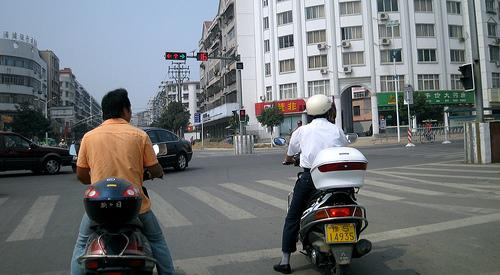In your own words, sum up the image contents in brief. Two bikers in colorful shirts on mopeds stop at a traffic light near a white corner building with green and white street signs. Briefly describe the setting and context of the image. An urban intersection featuring a white corner building, traffic lights, street signs, and two men riding mopeds. Provide a concise description of the most prominent features in the image. Two men on motorcycles stopped at a traffic light near a white building and crosswalk with traffic lights overhead. In one sentence, describe the action taking place in the image. Two men on mopeds pause at a traffic light near a white building and crosswalk. Provide a short and catchy caption for the image. "Motorcycle Diaries: Urban roads edition" Explain the type of scene being depicted in the image in one sentence. An urban street scene with two moped riders waiting at a traffic light intersection near a white building. Identify the three most noticeable objects in the image and their colors. Two riders wearing an orange and white shirt, a white building, and traffic lights over an intersection. Mention the key elements in the image and their positions related to each other. Two men ride mopeds near an intersection with traffic lights above, a white building on the corner and white lines of the crosswalk in front. Describe the most striking element from the image and explain why it's interesting. A man wearing an orange shirt is riding a moped, which stands out due to its vibrant color in the midst of the urban backdrop Describe the attire and position of the two individuals in the image. One man in an orange shirt and blue jeans, the other in a white shirt and white helmet, both riding mopeds at an intersection. 